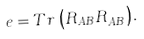<formula> <loc_0><loc_0><loc_500><loc_500>e = T r \, \left ( R _ { A B } R ^ { \dagger } _ { A B } \right ) .</formula> 